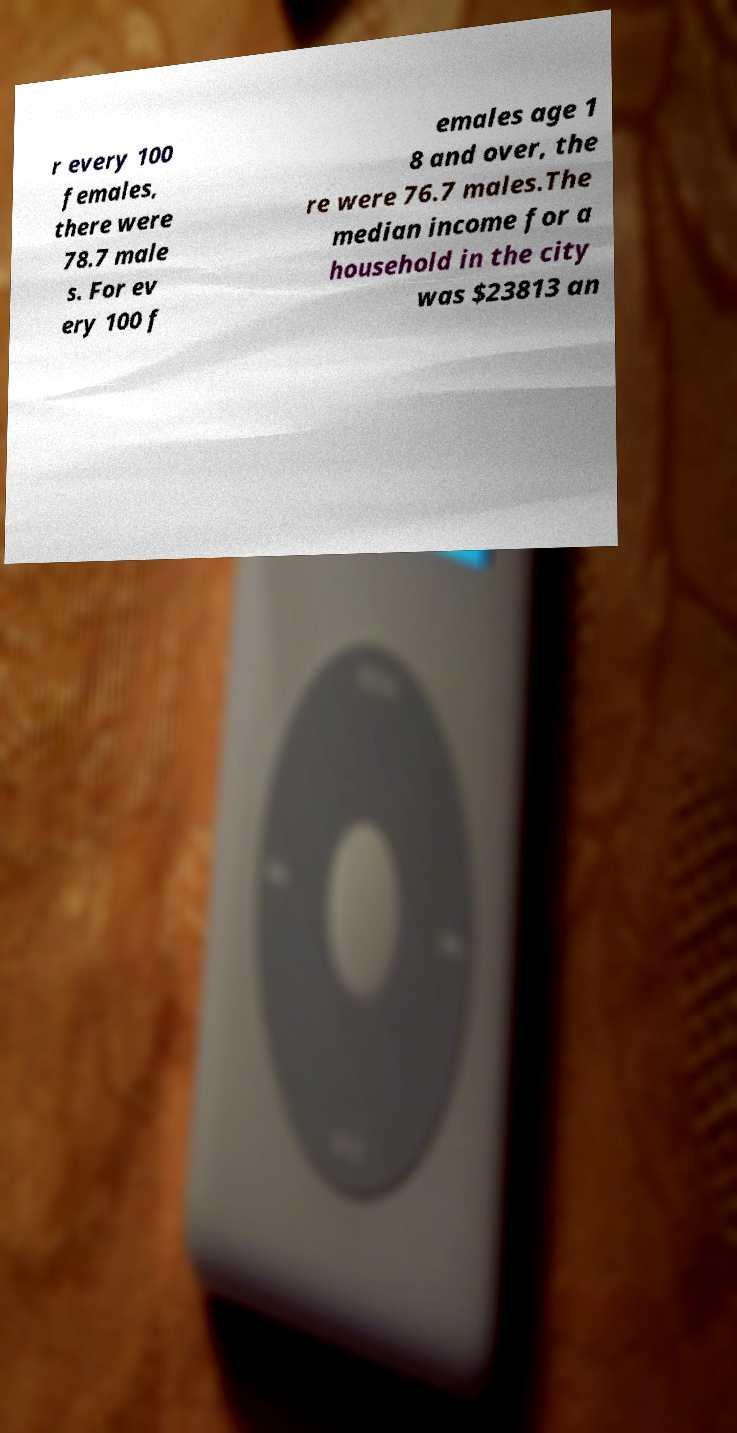Could you assist in decoding the text presented in this image and type it out clearly? r every 100 females, there were 78.7 male s. For ev ery 100 f emales age 1 8 and over, the re were 76.7 males.The median income for a household in the city was $23813 an 